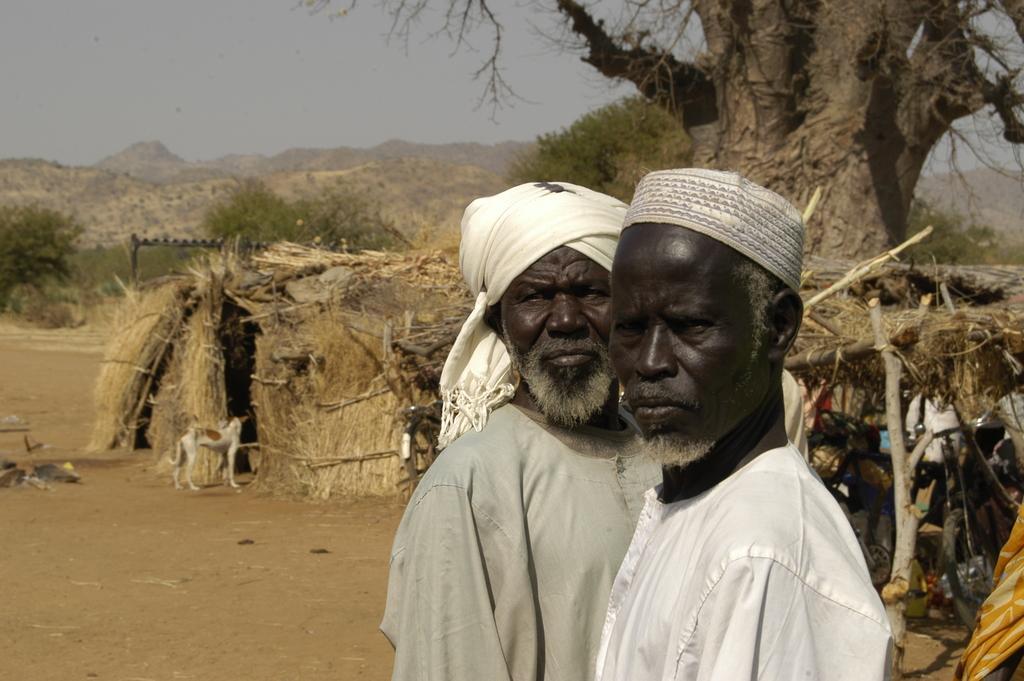How would you summarize this image in a sentence or two? There are two men. Here we can see a hot, dog, and trees. In the background we can see mountain and sky. 